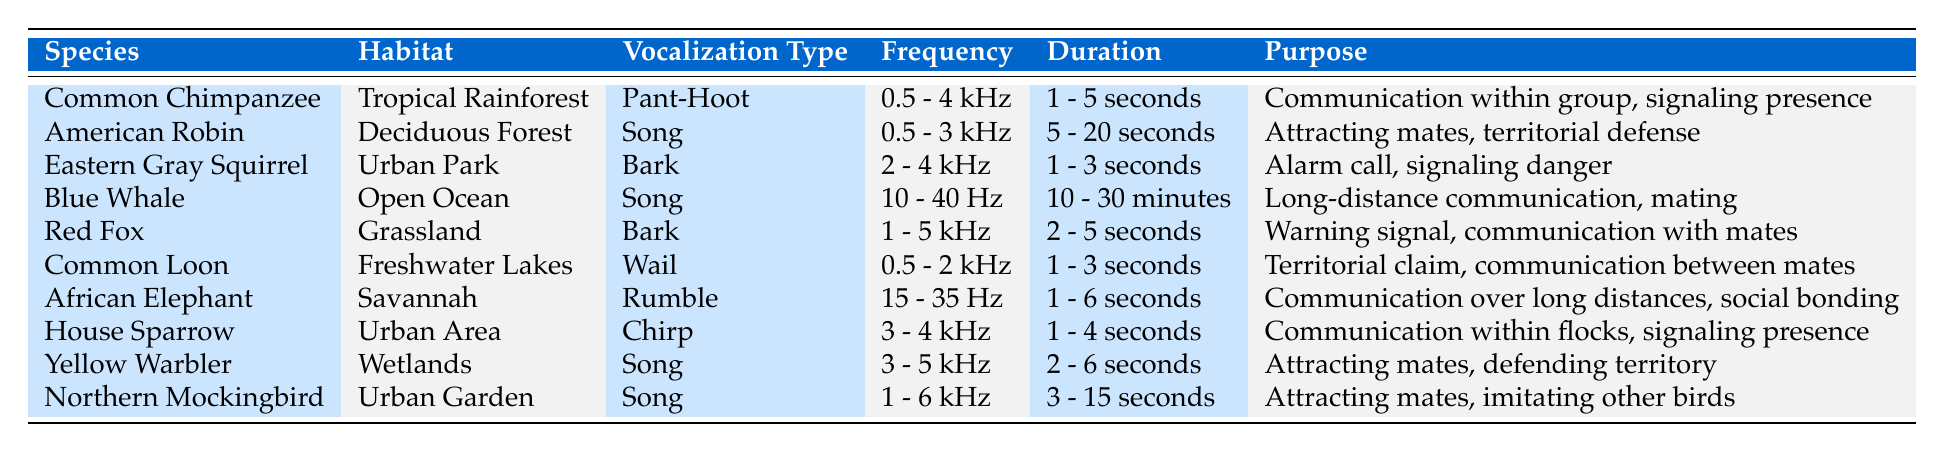What is the vocalization type of the Blue Whale? The table lists the vocalization type for the Blue Whale in the corresponding row. It is specified as "Song."
Answer: Song Which species utilizes a "Bark" vocalization type? By scanning through the table, we observe that both the Eastern Gray Squirrel and the Red Fox have the vocalization type "Bark."
Answer: Eastern Gray Squirrel and Red Fox What is the frequency range of the Yellow Warbler's vocalization? The table provides the frequency range for the Yellow Warbler in its row, which is "3 - 5 kHz."
Answer: 3 - 5 kHz Which animal has the longest vocalization duration? We check the duration column in the table; the Blue Whale has a duration of "10 - 30 minutes," which is significantly longer than any other species listed.
Answer: Blue Whale Do all animals in the table have a vocalization purpose related to communication? By examining the purpose column, we find that all listed purposes either mention communication or are related to social interaction, indicating that the statement is true.
Answer: Yes How many species use vocalizations with a frequency over 3 kHz? We analyze the frequency data in the table and count the species: Common Chimpanzee, Eastern Gray Squirrel, House Sparrow, Yellow Warbler, Northern Mockingbird. This gives us a total of five species.
Answer: 5 Which habitats are represented by species that use the "Song" vocalization type? Scanning the table for species with "Song" as their vocalization type, we find they are Common Chimpanzee, American Robin, Blue Whale, Yellow Warbler, and Northern Mockingbird. The corresponding habitats are Tropical Rainforest, Deciduous Forest, Open Ocean, Wetlands, and Urban Garden.
Answer: Tropical Rainforest, Deciduous Forest, Open Ocean, Wetlands, Urban Garden Which species has the shortest vocalization duration and what is it? We check the duration for each species. The Eastern Gray Squirrel and Common Loon have the shortest duration of "1 - 3 seconds."
Answer: Eastern Gray Squirrel and Common Loon Is the frequency range of the African Elephant higher or lower than that of the Common Chimpanzee? The frequency range of the African Elephant (15 - 35 Hz) is lower than that of the Common Chimpanzee (0.5 - 4 kHz), as the ranges suggest that the Chimpanzee vocalizes at higher frequencies.
Answer: Lower What is the average duration of vocalization for species that inhabit Urban areas? The species in Urban areas are Eastern Gray Squirrel (1 - 3 seconds) and House Sparrow (1 - 4 seconds). To find the average, we take the midpoints: 2 seconds for Squirrel and 2.5 seconds for Sparrow. (2 + 2.5) / 2 = 2.25 seconds.
Answer: 2.25 seconds 